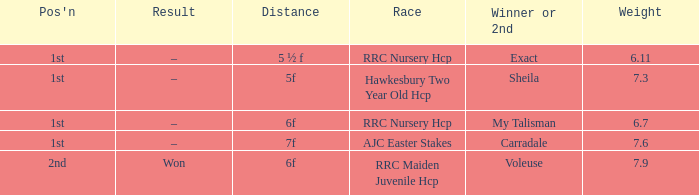Would you mind parsing the complete table? {'header': ["Pos'n", 'Result', 'Distance', 'Race', 'Winner or 2nd', 'Weight'], 'rows': [['1st', '–', '5 ½ f', 'RRC Nursery Hcp', 'Exact', '6.11'], ['1st', '–', '5f', 'Hawkesbury Two Year Old Hcp', 'Sheila', '7.3'], ['1st', '–', '6f', 'RRC Nursery Hcp', 'My Talisman', '6.7'], ['1st', '–', '7f', 'AJC Easter Stakes', 'Carradale', '7.6'], ['2nd', 'Won', '6f', 'RRC Maiden Juvenile Hcp', 'Voleuse', '7.9']]} What is the largest weight wth a Result of –, and a Distance of 7f? 7.6. 